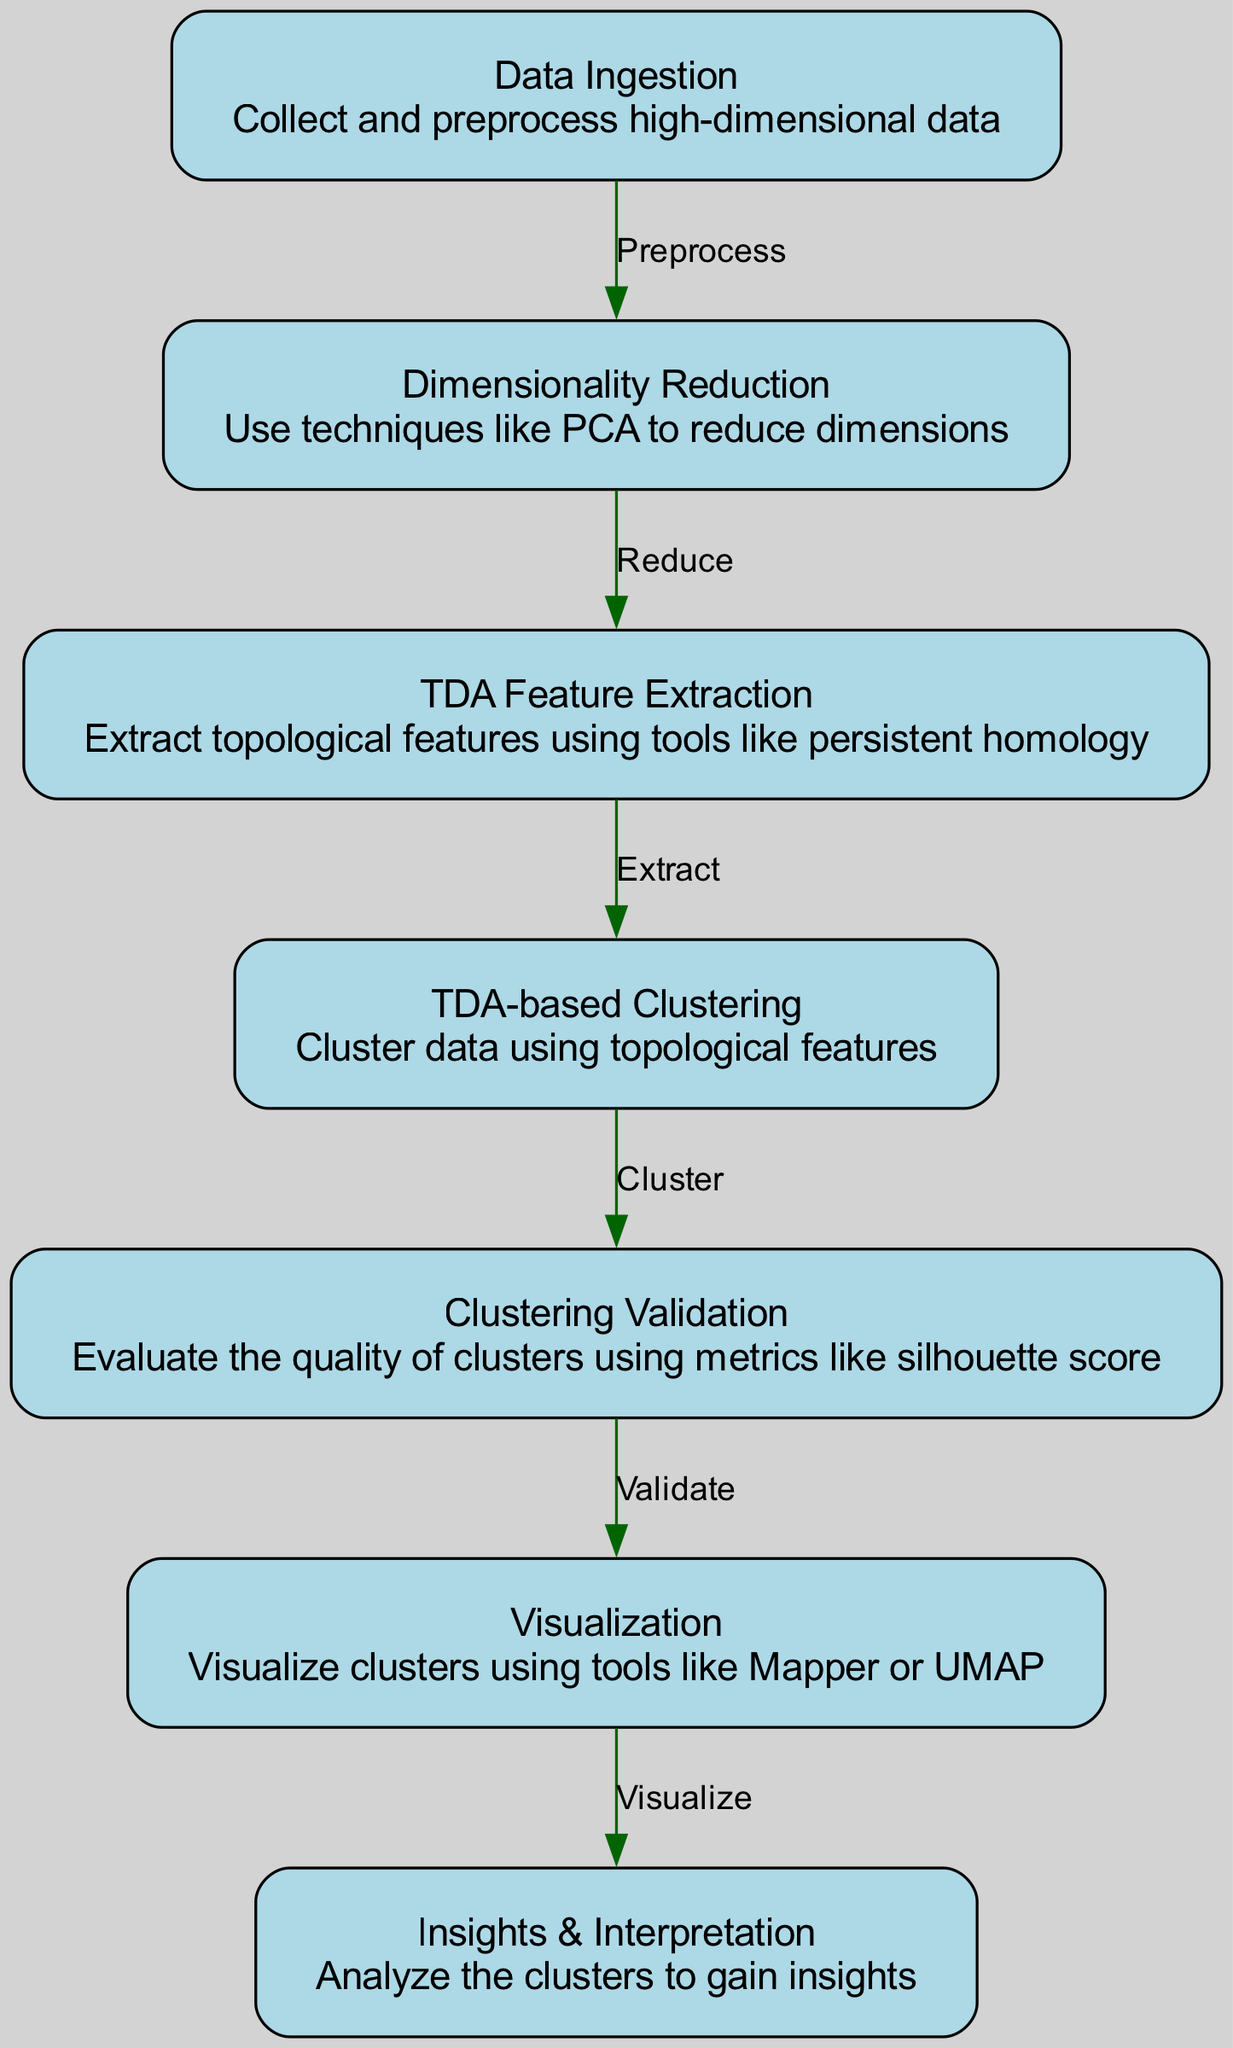What is the first step in the diagram? The first node in the diagram is "Data Ingestion", which collects and preprocesses high-dimensional data, indicating it's the initial step in the process.
Answer: Data Ingestion How many nodes are there in total? By counting each unique node listed in the diagram, there are seven nodes that represent different stages of the process.
Answer: Seven What connects "Dimensionality Reduction" to "TDA Feature Extraction"? The edge labeled "Reduce" connects "Dimensionality Reduction" to "TDA Feature Extraction", indicating the flow from reducing dimensions to extracting features.
Answer: Reduce Which node comes after "TDA Feature Extraction"? The next node that follows "TDA Feature Extraction" is "TDA-based Clustering", showing that extracted features are then used for clustering.
Answer: TDA-based Clustering What is evaluated during "Clustering Validation"? During the "Clustering Validation" phase, the quality of clusters is evaluated using metrics like silhouette score, which assesses how well the clusters are formed.
Answer: Quality of clusters What is the purpose of the "Visualization" node? The "Visualization" node visualizes the clusters created in the previous steps using tools like Mapper or UMAP, allowing for better interpretability of the clustering results.
Answer: Visualize clusters Which two nodes are directly linked by the edge "Cluster"? The edge "Cluster" connects the nodes "TDA-based Clustering" and "Clustering Validation", indicating that clustering leads to the validation of those clusters.
Answer: TDA-based Clustering and Clustering Validation What is the final outcome expressed in the diagram? The final output of the diagram is "Insights & Interpretation", which indicates that the analysis of the clusters leads to insights based on the earlier steps.
Answer: Insights & Interpretation 